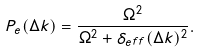<formula> <loc_0><loc_0><loc_500><loc_500>P _ { e } ( \Delta k ) = \frac { \Omega ^ { 2 } } { \Omega ^ { 2 } + \delta _ { e f f } ( \Delta k ) ^ { 2 } } .</formula> 